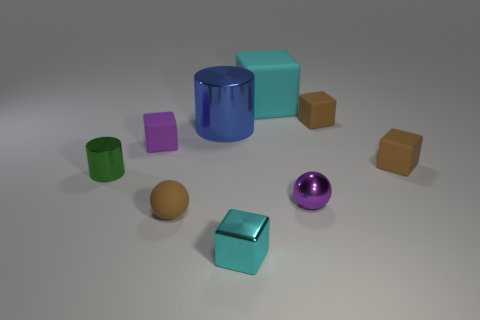What size is the block that is the same color as the large matte thing?
Offer a very short reply. Small. Is there a blue metallic cylinder of the same size as the rubber ball?
Give a very brief answer. No. Is the color of the ball that is on the left side of the small cyan metallic object the same as the metallic cylinder that is right of the tiny green metal object?
Offer a terse response. No. Is there a sphere that has the same color as the large rubber cube?
Your answer should be compact. No. How many other objects are there of the same shape as the large shiny object?
Provide a succinct answer. 1. What is the shape of the brown thing on the left side of the cyan matte thing?
Your answer should be compact. Sphere. Does the big blue thing have the same shape as the tiny brown object that is in front of the purple shiny sphere?
Your answer should be compact. No. There is a matte thing that is to the left of the cyan shiny cube and behind the brown sphere; how big is it?
Ensure brevity in your answer.  Small. There is a small object that is both on the left side of the tiny brown ball and behind the green cylinder; what is its color?
Your answer should be compact. Purple. Is there anything else that has the same material as the green thing?
Keep it short and to the point. Yes. 